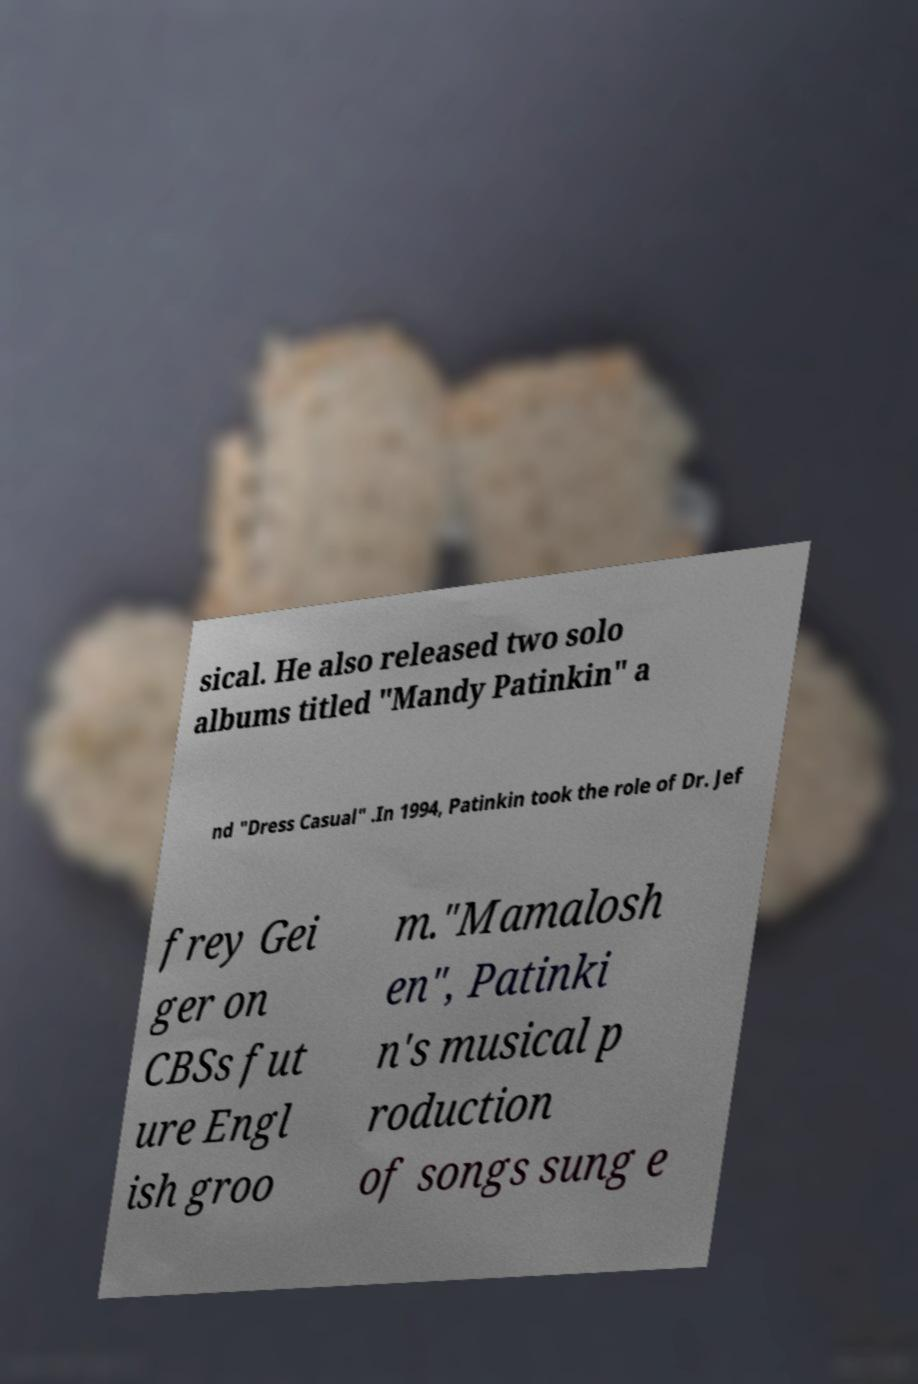Could you extract and type out the text from this image? sical. He also released two solo albums titled "Mandy Patinkin" a nd "Dress Casual" .In 1994, Patinkin took the role of Dr. Jef frey Gei ger on CBSs fut ure Engl ish groo m."Mamalosh en", Patinki n's musical p roduction of songs sung e 